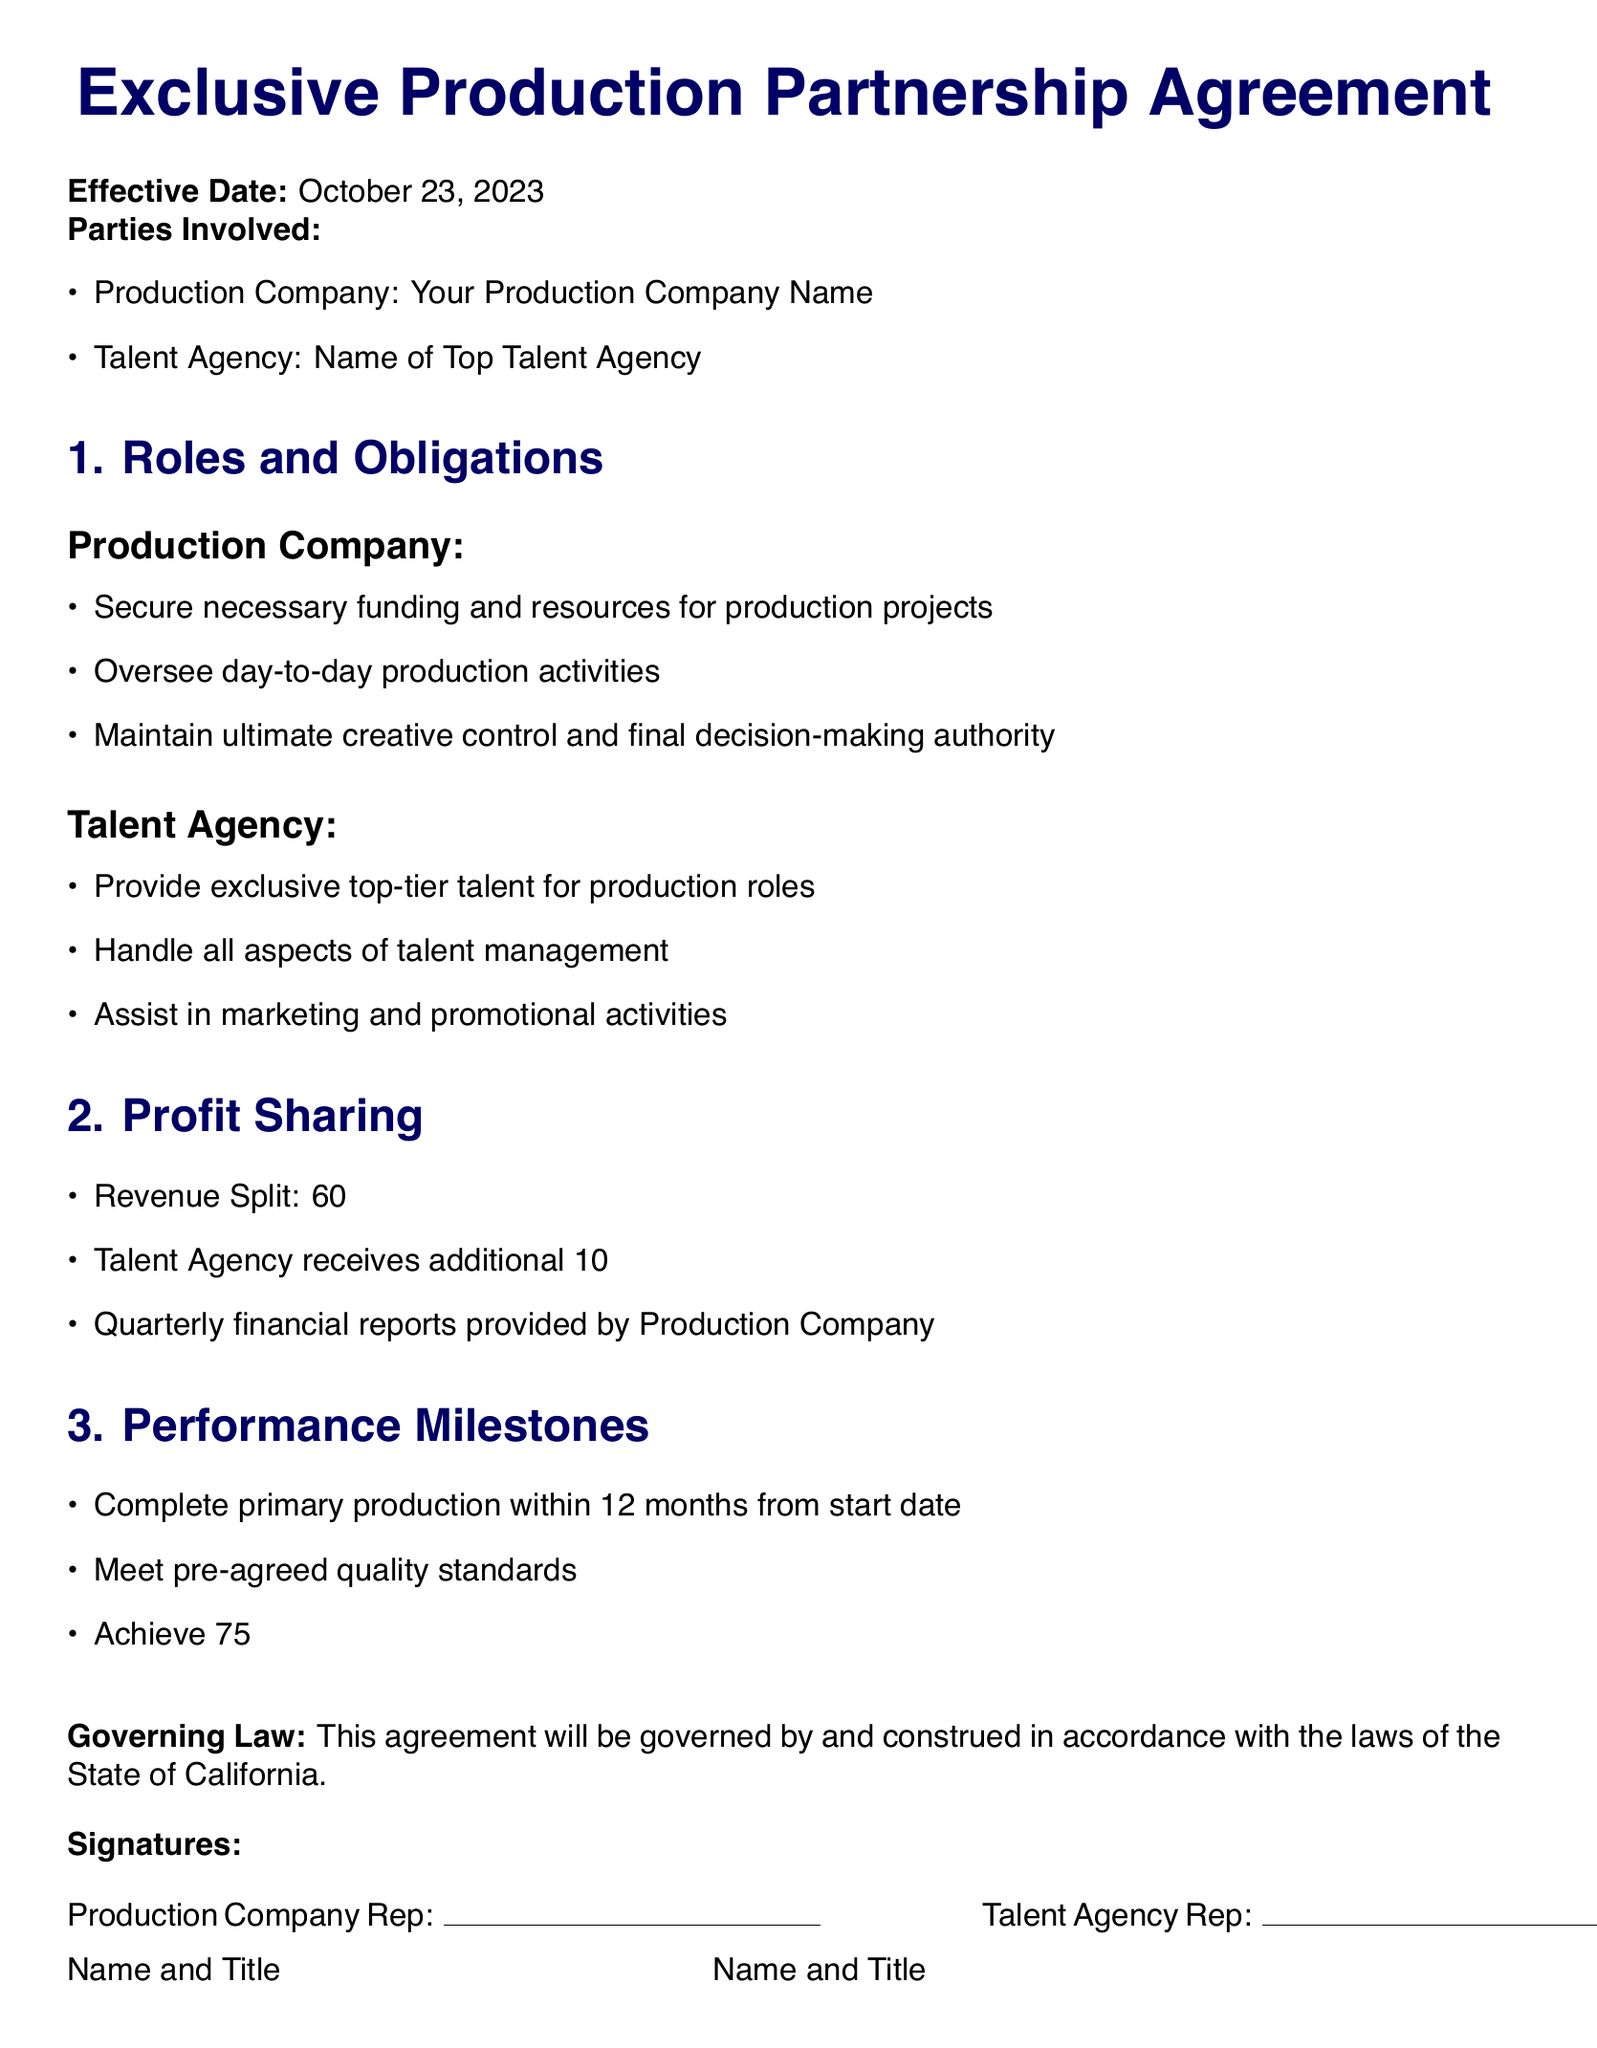What is the effective date of the agreement? The effective date is stated at the beginning of the document.
Answer: October 23, 2023 Who are the parties involved in this agreement? The parties involved are explicitly listed under the "Parties Involved" section.
Answer: Your Production Company Name and Name of Top Talent Agency What percentage of revenue does the Production Company receive? The revenue split is clearly outlined in the "Profit Sharing" section.
Answer: 60% What is the royalty percentage for the Talent Agency? The royalty percentage is specified in the "Profit Sharing" section.
Answer: 10% What is one of the performance milestones required? Performance milestones are listed in the "Performance Milestones" section.
Answer: Complete primary production within 12 months Which state governs this agreement? The governing law is mentioned at the end of the document.
Answer: California What does the Talent Agency handle? The obligations of the Talent Agency are detailed in the "Roles and Obligations" section.
Answer: All aspects of talent management What is the audience approval rating requirement? The audience approval rating is part of the performance milestones outlined in the document.
Answer: 75% What is the profit-sharing structure based on? The profit-sharing structure is defined in the "Profit Sharing" section, detailing the revenue split.
Answer: Revenue Split 